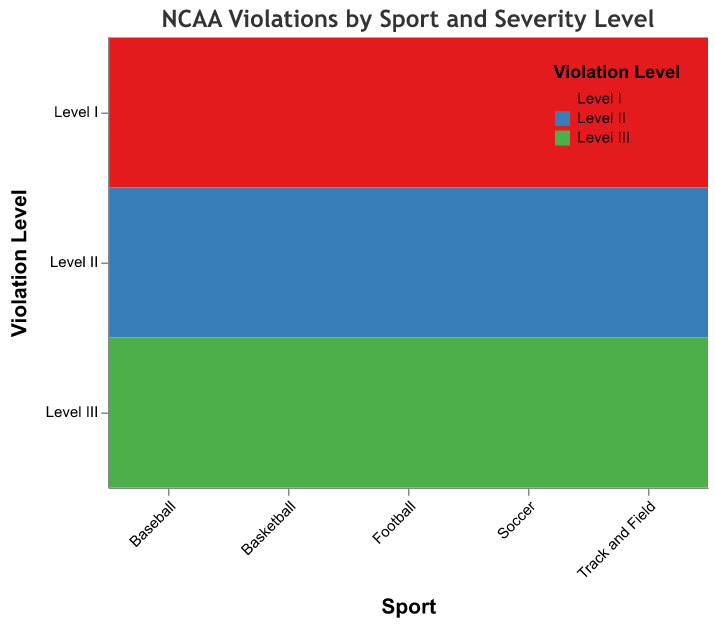what is the title of the plot? The title appears at the top of the figure and provides a description of what the plot is about. In this case, it is written above the plot area.
Answer: NCAA Violations by Sport and Severity Level Which sport has the most Level I violations? Find the bar corresponding to Level I violations and compare their heights across the sports categories to identify which one is the tallest.
Answer: Football How many Level II violations are there in Basketball? Look for the section of the plot under Basketball corresponding to Level II violations and check the specified count.
Answer: 62 Which sport has the fewest Level III violations? Compare the heights of the bars corresponding to Level III violations for each sport and identify the shortest one.
Answer: Soccer How does the number of Level I violations in Soccer compare to Level III violations in Baseball? Check the bar height for Level I violations in Soccer and Level III violations in Baseball, then state the difference in counts.
Answer: Soccer has fewer (9 vs. 83) Which violation level has the highest occurrence in Football? Look under Football and determine which bar representing a violation level is the tallest.
Answer: Level III What percentage of violations are Level III in Track and Field? Find the total violations in Track and Field (12 + 31 + 59) and calculate the percentage for Level III (59 / (12 + 31 + 59)).
Answer: Approximately 52% Is there a sport where Level II violations outnumber Level III violations? Compare the counts of Level II and Level III violations for each sport.
Answer: No In which sport is the ratio of Level I to Level III violations closest to 1? Calculate the ratio of Level I to Level III violations for each sport and see which one is closest to 1: Football (35/142), Basketball (28/95), Track and Field (12/59), Baseball (18/83), Soccer (9/47).
Answer: None (all ratios are far from 1) Which violation level has the smallest range of counts across all sports? Identify the minimum and maximum number of violations for each level across all sports, then calculate the range (max - min) for Levels I, II, and III. Compare these ranges.
Answer: Level I 